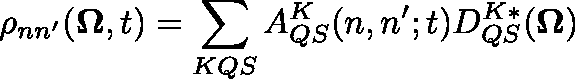<formula> <loc_0><loc_0><loc_500><loc_500>\rho _ { n n ^ { \prime } } ( \Omega , t ) = \sum _ { K Q S } A _ { Q S } ^ { K } ( n , n ^ { \prime } ; t ) D _ { Q S } ^ { K * } ( \Omega )</formula> 